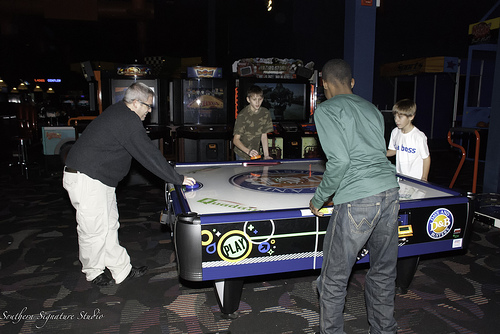<image>
Is the child to the right of the man? Yes. From this viewpoint, the child is positioned to the right side relative to the man. 